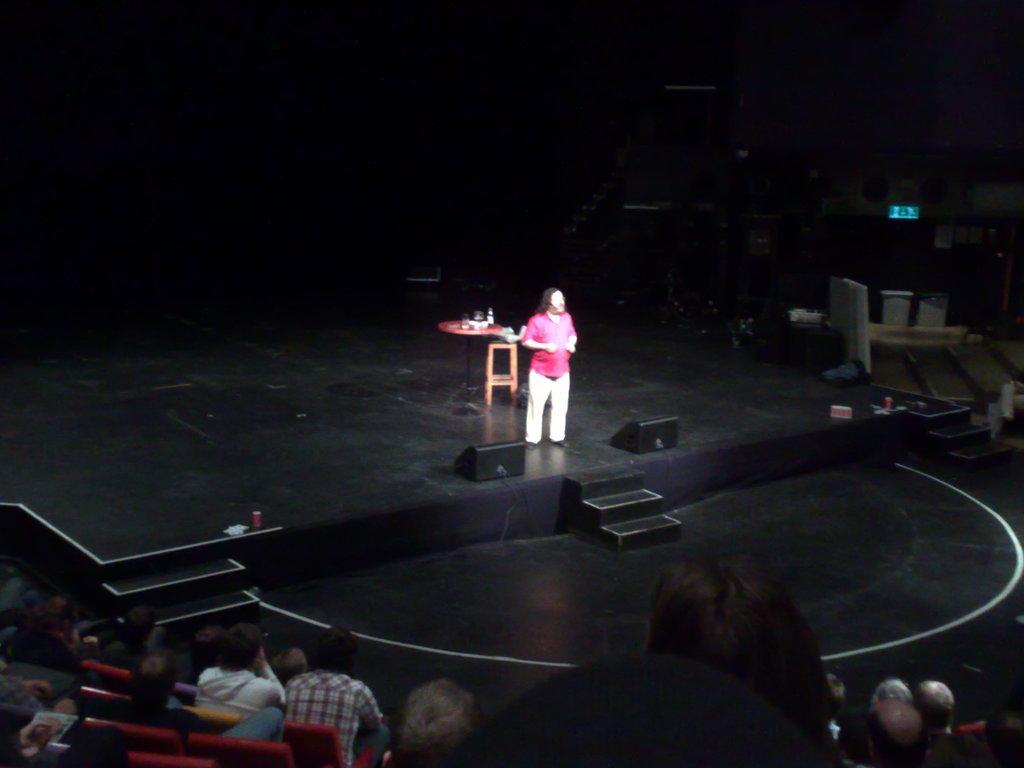In one or two sentences, can you explain what this image depicts? In the image we can see there is a person standing on the stage and there is a table on which there are glasses and bottle. In front there are spectators sitting on the chairs and watching the person on the stage. 